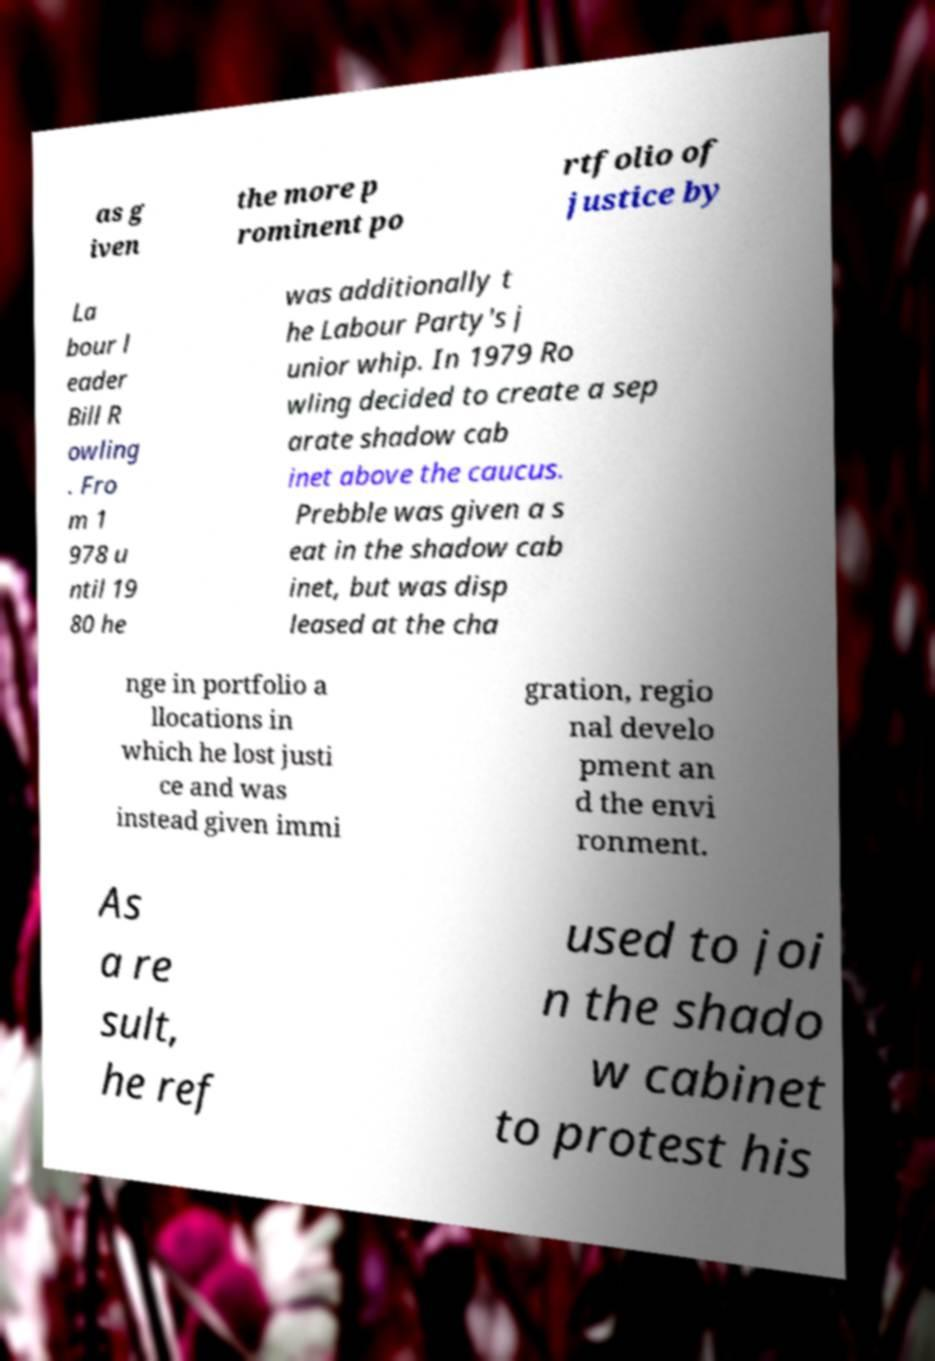Could you assist in decoding the text presented in this image and type it out clearly? as g iven the more p rominent po rtfolio of justice by La bour l eader Bill R owling . Fro m 1 978 u ntil 19 80 he was additionally t he Labour Party's j unior whip. In 1979 Ro wling decided to create a sep arate shadow cab inet above the caucus. Prebble was given a s eat in the shadow cab inet, but was disp leased at the cha nge in portfolio a llocations in which he lost justi ce and was instead given immi gration, regio nal develo pment an d the envi ronment. As a re sult, he ref used to joi n the shado w cabinet to protest his 